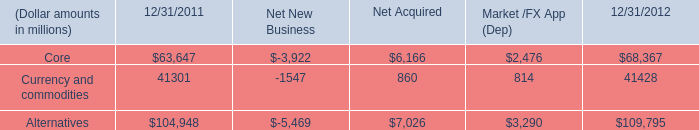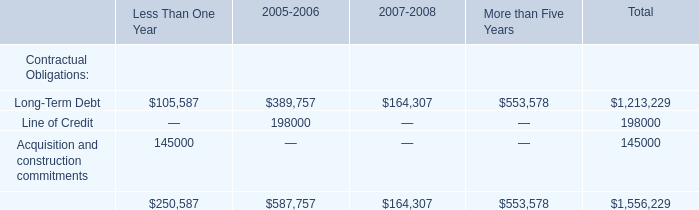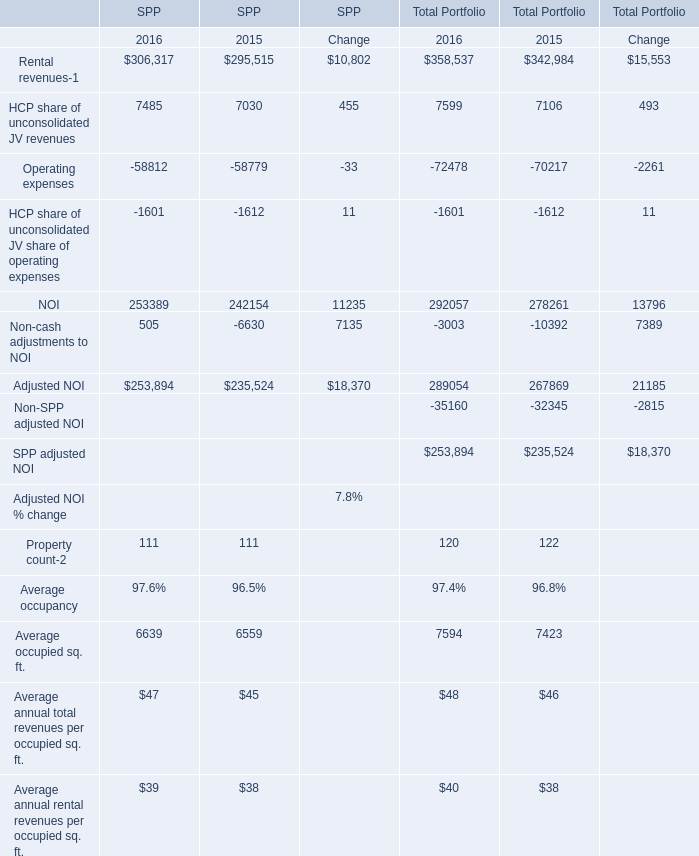what is the percentage change in the balance of alternative assets from 2011 to 2012? 
Computations: ((109795 - 104948) / 104948)
Answer: 0.04618. 